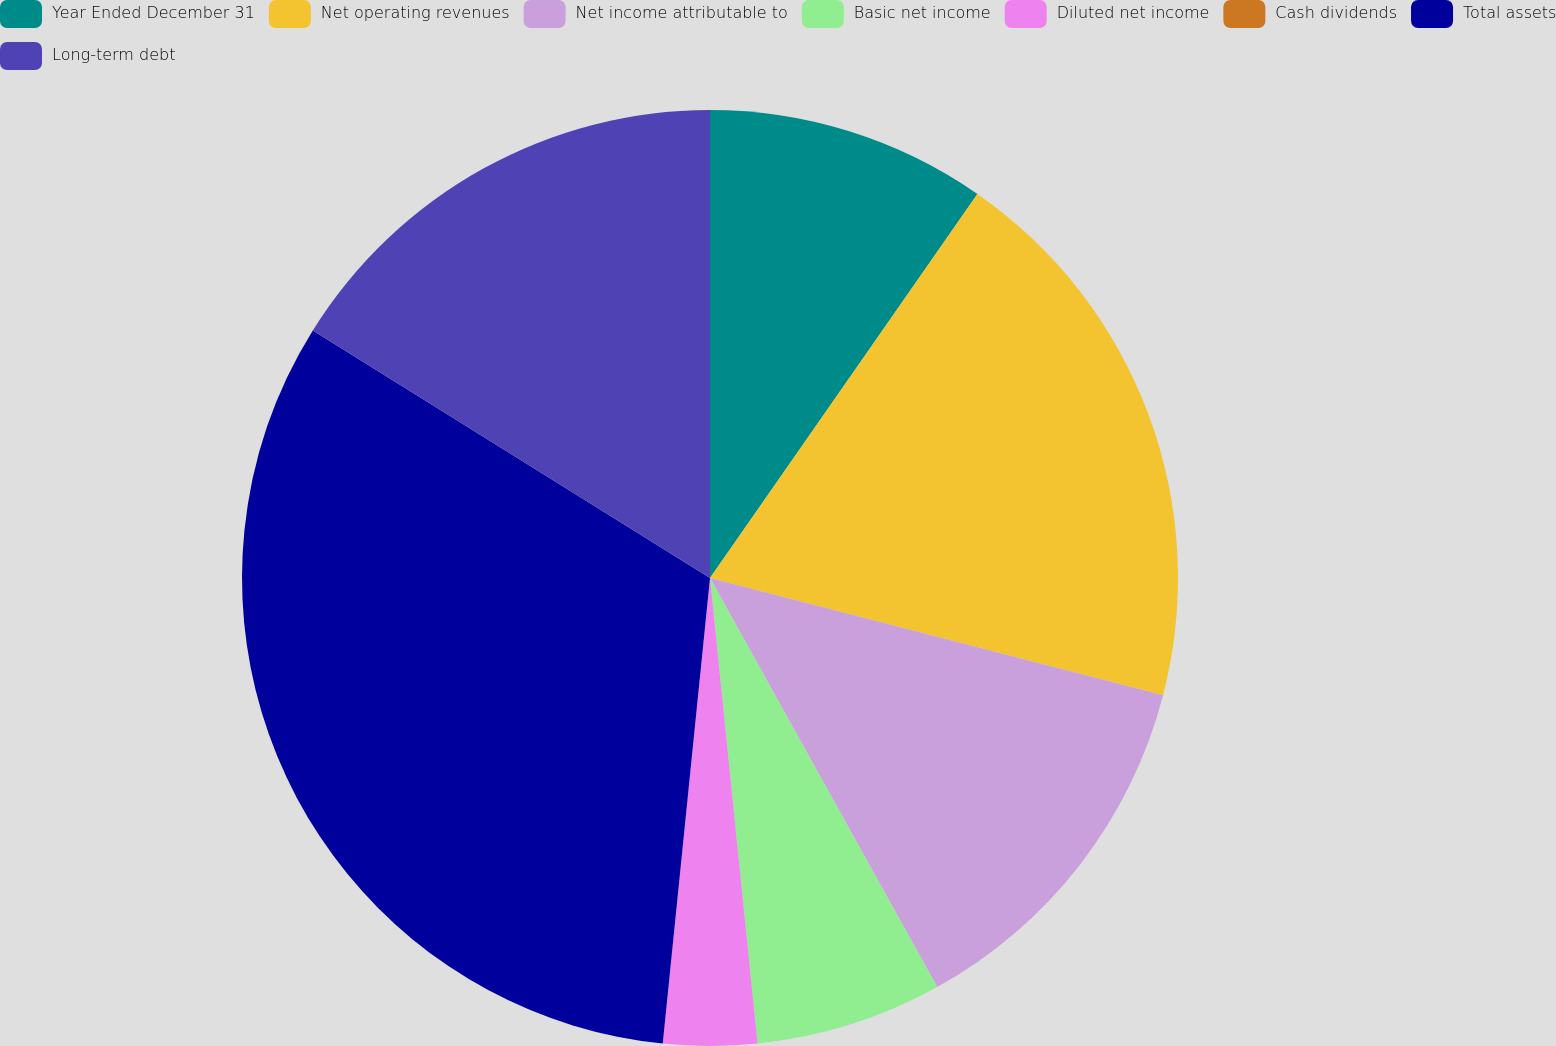Convert chart. <chart><loc_0><loc_0><loc_500><loc_500><pie_chart><fcel>Year Ended December 31<fcel>Net operating revenues<fcel>Net income attributable to<fcel>Basic net income<fcel>Diluted net income<fcel>Cash dividends<fcel>Total assets<fcel>Long-term debt<nl><fcel>9.68%<fcel>19.35%<fcel>12.9%<fcel>6.45%<fcel>3.23%<fcel>0.0%<fcel>32.26%<fcel>16.13%<nl></chart> 